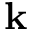Convert formula to latex. <formula><loc_0><loc_0><loc_500><loc_500>k</formula> 